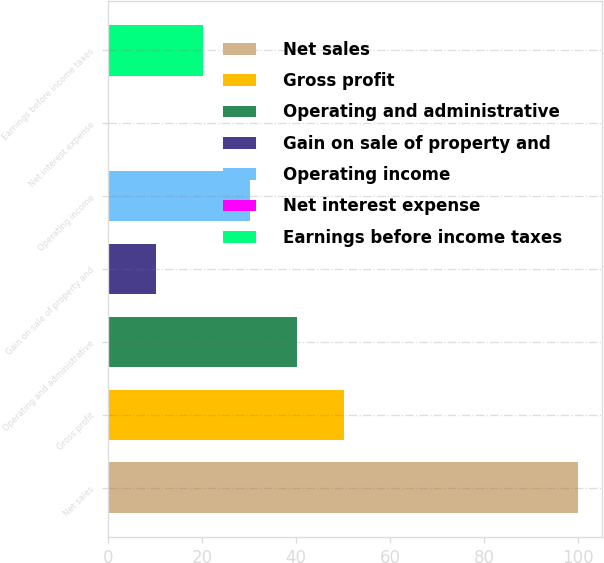Convert chart to OTSL. <chart><loc_0><loc_0><loc_500><loc_500><bar_chart><fcel>Net sales<fcel>Gross profit<fcel>Operating and administrative<fcel>Gain on sale of property and<fcel>Operating income<fcel>Net interest expense<fcel>Earnings before income taxes<nl><fcel>100<fcel>50.1<fcel>40.12<fcel>10.18<fcel>30.14<fcel>0.2<fcel>20.16<nl></chart> 